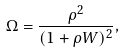<formula> <loc_0><loc_0><loc_500><loc_500>\Omega = \frac { \rho ^ { 2 } } { ( 1 + \rho W ) ^ { 2 } } ,</formula> 